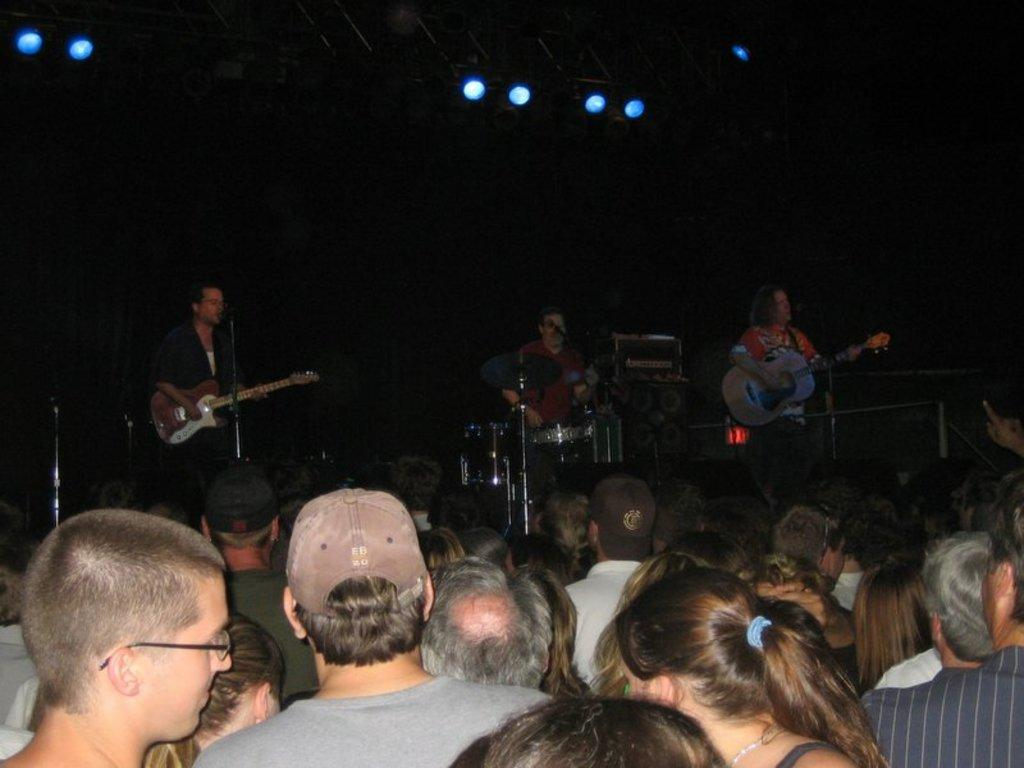What is the main subject of the image? The main subject of the image is a group of people. What can be seen in the background of the image? In the background of the image, there are persons holding musical instruments. Are there any additional elements visible in the background? Yes, there are lights visible in the background of the image. What type of tin can be seen being woven with yarn in the image? There is no tin or yarn present in the image. What color is the cub in the image? There is no cub present in the image. 